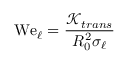Convert formula to latex. <formula><loc_0><loc_0><loc_500><loc_500>W e _ { \ell } = \frac { \mathcal { K } _ { t r a n s } } { R _ { 0 } ^ { 2 } \sigma _ { \ell } }</formula> 